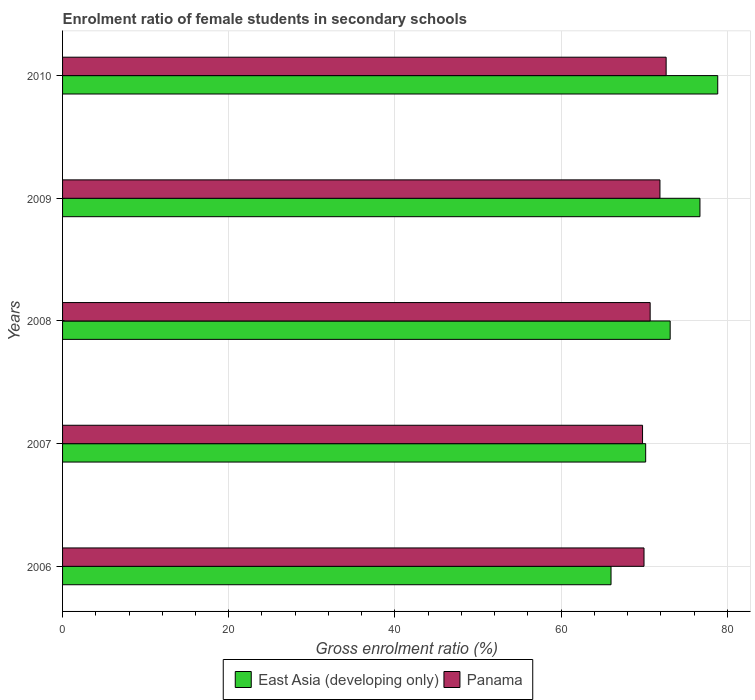How many groups of bars are there?
Ensure brevity in your answer.  5. Are the number of bars per tick equal to the number of legend labels?
Offer a very short reply. Yes. Are the number of bars on each tick of the Y-axis equal?
Your answer should be compact. Yes. In how many cases, is the number of bars for a given year not equal to the number of legend labels?
Your response must be concise. 0. What is the enrolment ratio of female students in secondary schools in Panama in 2008?
Provide a succinct answer. 70.72. Across all years, what is the maximum enrolment ratio of female students in secondary schools in East Asia (developing only)?
Offer a terse response. 78.86. Across all years, what is the minimum enrolment ratio of female students in secondary schools in East Asia (developing only)?
Provide a short and direct response. 66.01. In which year was the enrolment ratio of female students in secondary schools in Panama maximum?
Your answer should be compact. 2010. In which year was the enrolment ratio of female students in secondary schools in East Asia (developing only) minimum?
Offer a terse response. 2006. What is the total enrolment ratio of female students in secondary schools in East Asia (developing only) in the graph?
Ensure brevity in your answer.  364.89. What is the difference between the enrolment ratio of female students in secondary schools in Panama in 2007 and that in 2010?
Offer a terse response. -2.84. What is the difference between the enrolment ratio of female students in secondary schools in East Asia (developing only) in 2009 and the enrolment ratio of female students in secondary schools in Panama in 2008?
Provide a short and direct response. 5.99. What is the average enrolment ratio of female students in secondary schools in East Asia (developing only) per year?
Ensure brevity in your answer.  72.98. In the year 2008, what is the difference between the enrolment ratio of female students in secondary schools in Panama and enrolment ratio of female students in secondary schools in East Asia (developing only)?
Ensure brevity in your answer.  -2.41. What is the ratio of the enrolment ratio of female students in secondary schools in East Asia (developing only) in 2008 to that in 2010?
Provide a short and direct response. 0.93. What is the difference between the highest and the second highest enrolment ratio of female students in secondary schools in Panama?
Offer a terse response. 0.74. What is the difference between the highest and the lowest enrolment ratio of female students in secondary schools in East Asia (developing only)?
Give a very brief answer. 12.84. What does the 1st bar from the top in 2009 represents?
Make the answer very short. Panama. What does the 1st bar from the bottom in 2010 represents?
Ensure brevity in your answer.  East Asia (developing only). Are all the bars in the graph horizontal?
Ensure brevity in your answer.  Yes. Are the values on the major ticks of X-axis written in scientific E-notation?
Provide a short and direct response. No. Does the graph contain any zero values?
Your answer should be very brief. No. Does the graph contain grids?
Ensure brevity in your answer.  Yes. Where does the legend appear in the graph?
Your answer should be very brief. Bottom center. What is the title of the graph?
Provide a short and direct response. Enrolment ratio of female students in secondary schools. What is the label or title of the X-axis?
Make the answer very short. Gross enrolment ratio (%). What is the Gross enrolment ratio (%) of East Asia (developing only) in 2006?
Your answer should be compact. 66.01. What is the Gross enrolment ratio (%) of Panama in 2006?
Keep it short and to the point. 69.98. What is the Gross enrolment ratio (%) in East Asia (developing only) in 2007?
Your answer should be very brief. 70.18. What is the Gross enrolment ratio (%) in Panama in 2007?
Your response must be concise. 69.81. What is the Gross enrolment ratio (%) of East Asia (developing only) in 2008?
Make the answer very short. 73.13. What is the Gross enrolment ratio (%) of Panama in 2008?
Provide a short and direct response. 70.72. What is the Gross enrolment ratio (%) in East Asia (developing only) in 2009?
Your answer should be compact. 76.71. What is the Gross enrolment ratio (%) of Panama in 2009?
Your answer should be very brief. 71.9. What is the Gross enrolment ratio (%) of East Asia (developing only) in 2010?
Your answer should be very brief. 78.86. What is the Gross enrolment ratio (%) of Panama in 2010?
Your answer should be compact. 72.65. Across all years, what is the maximum Gross enrolment ratio (%) of East Asia (developing only)?
Give a very brief answer. 78.86. Across all years, what is the maximum Gross enrolment ratio (%) of Panama?
Your answer should be very brief. 72.65. Across all years, what is the minimum Gross enrolment ratio (%) in East Asia (developing only)?
Your answer should be very brief. 66.01. Across all years, what is the minimum Gross enrolment ratio (%) of Panama?
Ensure brevity in your answer.  69.81. What is the total Gross enrolment ratio (%) of East Asia (developing only) in the graph?
Give a very brief answer. 364.89. What is the total Gross enrolment ratio (%) of Panama in the graph?
Offer a very short reply. 355.06. What is the difference between the Gross enrolment ratio (%) in East Asia (developing only) in 2006 and that in 2007?
Offer a terse response. -4.17. What is the difference between the Gross enrolment ratio (%) of Panama in 2006 and that in 2007?
Keep it short and to the point. 0.18. What is the difference between the Gross enrolment ratio (%) of East Asia (developing only) in 2006 and that in 2008?
Offer a very short reply. -7.12. What is the difference between the Gross enrolment ratio (%) in Panama in 2006 and that in 2008?
Ensure brevity in your answer.  -0.74. What is the difference between the Gross enrolment ratio (%) of East Asia (developing only) in 2006 and that in 2009?
Your answer should be very brief. -10.7. What is the difference between the Gross enrolment ratio (%) of Panama in 2006 and that in 2009?
Keep it short and to the point. -1.92. What is the difference between the Gross enrolment ratio (%) of East Asia (developing only) in 2006 and that in 2010?
Give a very brief answer. -12.84. What is the difference between the Gross enrolment ratio (%) in Panama in 2006 and that in 2010?
Offer a terse response. -2.66. What is the difference between the Gross enrolment ratio (%) in East Asia (developing only) in 2007 and that in 2008?
Give a very brief answer. -2.95. What is the difference between the Gross enrolment ratio (%) in Panama in 2007 and that in 2008?
Offer a very short reply. -0.92. What is the difference between the Gross enrolment ratio (%) of East Asia (developing only) in 2007 and that in 2009?
Your answer should be very brief. -6.53. What is the difference between the Gross enrolment ratio (%) in Panama in 2007 and that in 2009?
Your answer should be compact. -2.1. What is the difference between the Gross enrolment ratio (%) in East Asia (developing only) in 2007 and that in 2010?
Ensure brevity in your answer.  -8.67. What is the difference between the Gross enrolment ratio (%) in Panama in 2007 and that in 2010?
Your answer should be compact. -2.84. What is the difference between the Gross enrolment ratio (%) of East Asia (developing only) in 2008 and that in 2009?
Provide a succinct answer. -3.58. What is the difference between the Gross enrolment ratio (%) in Panama in 2008 and that in 2009?
Your answer should be compact. -1.18. What is the difference between the Gross enrolment ratio (%) of East Asia (developing only) in 2008 and that in 2010?
Provide a short and direct response. -5.73. What is the difference between the Gross enrolment ratio (%) in Panama in 2008 and that in 2010?
Your answer should be very brief. -1.92. What is the difference between the Gross enrolment ratio (%) in East Asia (developing only) in 2009 and that in 2010?
Offer a very short reply. -2.14. What is the difference between the Gross enrolment ratio (%) of Panama in 2009 and that in 2010?
Provide a succinct answer. -0.74. What is the difference between the Gross enrolment ratio (%) of East Asia (developing only) in 2006 and the Gross enrolment ratio (%) of Panama in 2007?
Keep it short and to the point. -3.79. What is the difference between the Gross enrolment ratio (%) of East Asia (developing only) in 2006 and the Gross enrolment ratio (%) of Panama in 2008?
Provide a short and direct response. -4.71. What is the difference between the Gross enrolment ratio (%) in East Asia (developing only) in 2006 and the Gross enrolment ratio (%) in Panama in 2009?
Make the answer very short. -5.89. What is the difference between the Gross enrolment ratio (%) in East Asia (developing only) in 2006 and the Gross enrolment ratio (%) in Panama in 2010?
Offer a very short reply. -6.63. What is the difference between the Gross enrolment ratio (%) of East Asia (developing only) in 2007 and the Gross enrolment ratio (%) of Panama in 2008?
Your response must be concise. -0.54. What is the difference between the Gross enrolment ratio (%) of East Asia (developing only) in 2007 and the Gross enrolment ratio (%) of Panama in 2009?
Provide a short and direct response. -1.72. What is the difference between the Gross enrolment ratio (%) in East Asia (developing only) in 2007 and the Gross enrolment ratio (%) in Panama in 2010?
Offer a very short reply. -2.46. What is the difference between the Gross enrolment ratio (%) in East Asia (developing only) in 2008 and the Gross enrolment ratio (%) in Panama in 2009?
Your answer should be compact. 1.23. What is the difference between the Gross enrolment ratio (%) in East Asia (developing only) in 2008 and the Gross enrolment ratio (%) in Panama in 2010?
Provide a succinct answer. 0.48. What is the difference between the Gross enrolment ratio (%) of East Asia (developing only) in 2009 and the Gross enrolment ratio (%) of Panama in 2010?
Offer a very short reply. 4.07. What is the average Gross enrolment ratio (%) of East Asia (developing only) per year?
Offer a very short reply. 72.98. What is the average Gross enrolment ratio (%) of Panama per year?
Your answer should be compact. 71.01. In the year 2006, what is the difference between the Gross enrolment ratio (%) in East Asia (developing only) and Gross enrolment ratio (%) in Panama?
Offer a very short reply. -3.97. In the year 2007, what is the difference between the Gross enrolment ratio (%) in East Asia (developing only) and Gross enrolment ratio (%) in Panama?
Your response must be concise. 0.38. In the year 2008, what is the difference between the Gross enrolment ratio (%) of East Asia (developing only) and Gross enrolment ratio (%) of Panama?
Make the answer very short. 2.41. In the year 2009, what is the difference between the Gross enrolment ratio (%) in East Asia (developing only) and Gross enrolment ratio (%) in Panama?
Provide a short and direct response. 4.81. In the year 2010, what is the difference between the Gross enrolment ratio (%) in East Asia (developing only) and Gross enrolment ratio (%) in Panama?
Provide a succinct answer. 6.21. What is the ratio of the Gross enrolment ratio (%) in East Asia (developing only) in 2006 to that in 2007?
Your response must be concise. 0.94. What is the ratio of the Gross enrolment ratio (%) of Panama in 2006 to that in 2007?
Ensure brevity in your answer.  1. What is the ratio of the Gross enrolment ratio (%) in East Asia (developing only) in 2006 to that in 2008?
Offer a very short reply. 0.9. What is the ratio of the Gross enrolment ratio (%) of Panama in 2006 to that in 2008?
Offer a very short reply. 0.99. What is the ratio of the Gross enrolment ratio (%) of East Asia (developing only) in 2006 to that in 2009?
Your answer should be compact. 0.86. What is the ratio of the Gross enrolment ratio (%) of Panama in 2006 to that in 2009?
Your response must be concise. 0.97. What is the ratio of the Gross enrolment ratio (%) of East Asia (developing only) in 2006 to that in 2010?
Make the answer very short. 0.84. What is the ratio of the Gross enrolment ratio (%) in Panama in 2006 to that in 2010?
Keep it short and to the point. 0.96. What is the ratio of the Gross enrolment ratio (%) in East Asia (developing only) in 2007 to that in 2008?
Your response must be concise. 0.96. What is the ratio of the Gross enrolment ratio (%) of East Asia (developing only) in 2007 to that in 2009?
Ensure brevity in your answer.  0.91. What is the ratio of the Gross enrolment ratio (%) in Panama in 2007 to that in 2009?
Offer a very short reply. 0.97. What is the ratio of the Gross enrolment ratio (%) of East Asia (developing only) in 2007 to that in 2010?
Give a very brief answer. 0.89. What is the ratio of the Gross enrolment ratio (%) in Panama in 2007 to that in 2010?
Give a very brief answer. 0.96. What is the ratio of the Gross enrolment ratio (%) in East Asia (developing only) in 2008 to that in 2009?
Your response must be concise. 0.95. What is the ratio of the Gross enrolment ratio (%) in Panama in 2008 to that in 2009?
Your answer should be very brief. 0.98. What is the ratio of the Gross enrolment ratio (%) of East Asia (developing only) in 2008 to that in 2010?
Give a very brief answer. 0.93. What is the ratio of the Gross enrolment ratio (%) in Panama in 2008 to that in 2010?
Provide a short and direct response. 0.97. What is the ratio of the Gross enrolment ratio (%) in East Asia (developing only) in 2009 to that in 2010?
Your answer should be very brief. 0.97. What is the difference between the highest and the second highest Gross enrolment ratio (%) in East Asia (developing only)?
Make the answer very short. 2.14. What is the difference between the highest and the second highest Gross enrolment ratio (%) in Panama?
Ensure brevity in your answer.  0.74. What is the difference between the highest and the lowest Gross enrolment ratio (%) of East Asia (developing only)?
Your answer should be very brief. 12.84. What is the difference between the highest and the lowest Gross enrolment ratio (%) in Panama?
Your response must be concise. 2.84. 